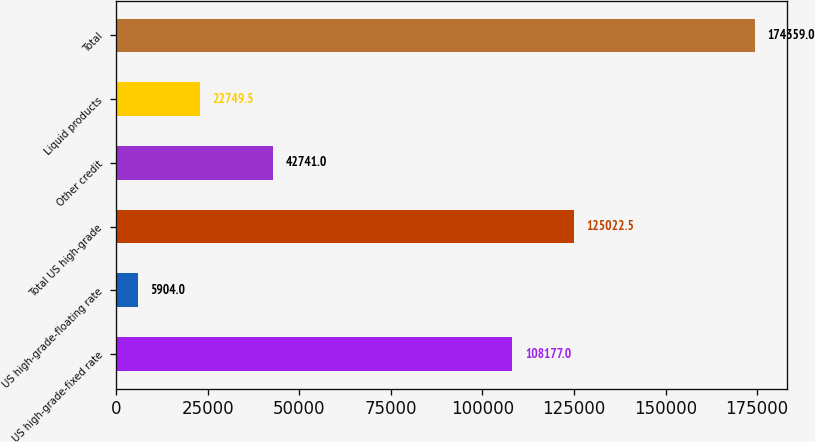Convert chart. <chart><loc_0><loc_0><loc_500><loc_500><bar_chart><fcel>US high-grade-fixed rate<fcel>US high-grade-floating rate<fcel>Total US high-grade<fcel>Other credit<fcel>Liquid products<fcel>Total<nl><fcel>108177<fcel>5904<fcel>125022<fcel>42741<fcel>22749.5<fcel>174359<nl></chart> 